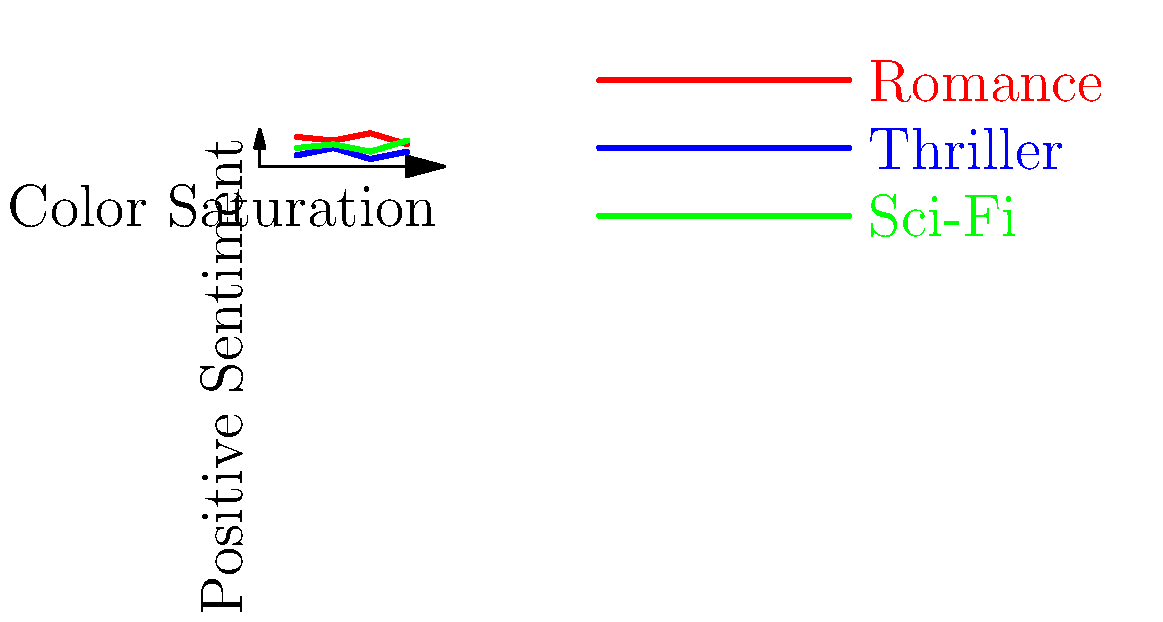Based on the sentiment analysis of book cover layouts across different genres shown in the graph, which genre consistently demonstrates the highest positive sentiment correlation with increasing color saturation, and how might this insight be leveraged in negotiations for screen adaptations? To answer this question, we need to analyze the graph and follow these steps:

1. Examine the trend lines for each genre:
   - Romance (red line): Shows a generally high and consistent positive sentiment.
   - Thriller (blue line): Displays lower positive sentiment with slight fluctuations.
   - Sci-Fi (green line): Exhibits moderate positive sentiment with an upward trend.

2. Identify the genre with the highest and most consistent positive sentiment:
   - Romance maintains the highest position on the graph throughout the color saturation range.
   - It shows less fluctuation compared to the other genres.

3. Interpret the correlation between color saturation and positive sentiment:
   - For Romance, there's a strong and consistent positive correlation.
   - This suggests that highly saturated colors in Romance book covers are associated with more positive sentiment.

4. Consider the implications for screen adaptations:
   - The strong positive sentiment associated with Romance covers could indicate a higher emotional engagement from the audience.
   - This emotional connection might translate to a more enthusiastic reception of screen adaptations.

5. Leverage this insight in negotiations:
   - Argue that the consistent positive sentiment in Romance genre indicates a strong, emotionally invested audience.
   - Suggest that this emotional investment could lead to higher viewer engagement and potentially better performance for screen adaptations.
   - Propose that marketing strategies for screen adaptations could benefit from using highly saturated color schemes to evoke similar positive sentiments.

In conclusion, the Romance genre shows the highest and most consistent positive sentiment correlation with increasing color saturation. This insight can be used to negotiate better terms for screen adaptations by emphasizing the potential for strong audience engagement and effective marketing strategies.
Answer: Romance; leverage emotional audience connection for adaptation success 